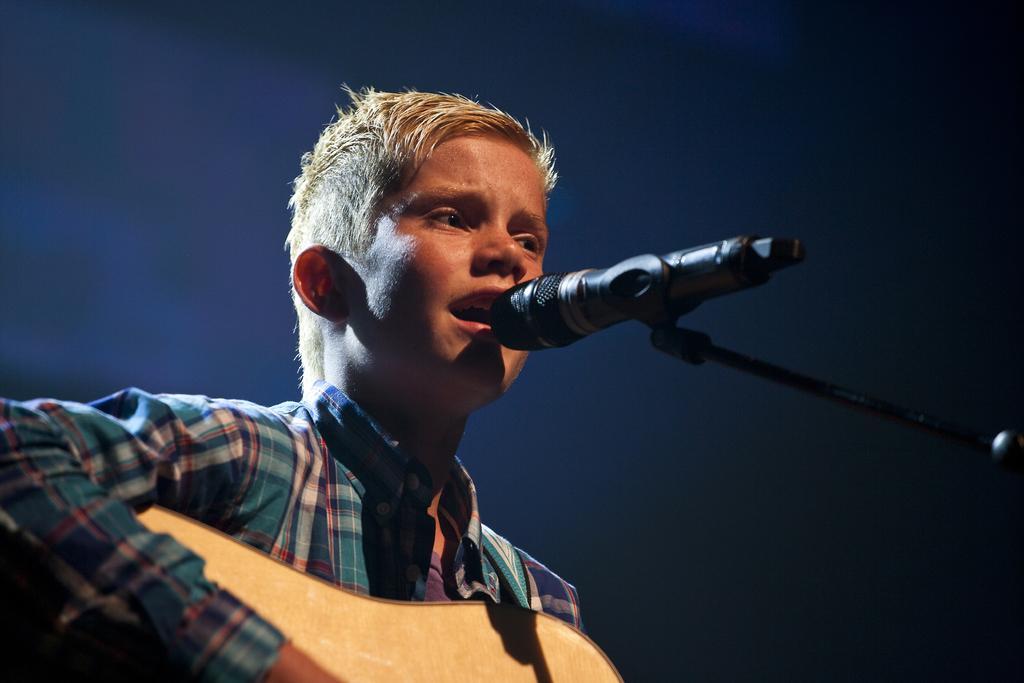In one or two sentences, can you explain what this image depicts? Here in this picture we can see a person singing a song in the microphone present in front of him and we can see he is playing guitar present in his hands. 